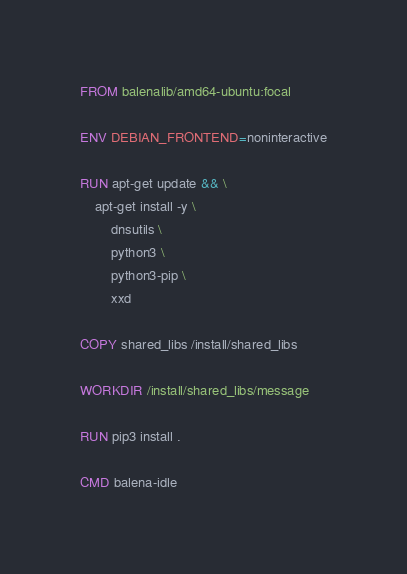<code> <loc_0><loc_0><loc_500><loc_500><_Dockerfile_>FROM balenalib/amd64-ubuntu:focal

ENV DEBIAN_FRONTEND=noninteractive

RUN apt-get update && \
    apt-get install -y \
        dnsutils \
        python3 \
        python3-pip \
        xxd

COPY shared_libs /install/shared_libs

WORKDIR /install/shared_libs/message

RUN pip3 install .

CMD balena-idle</code> 